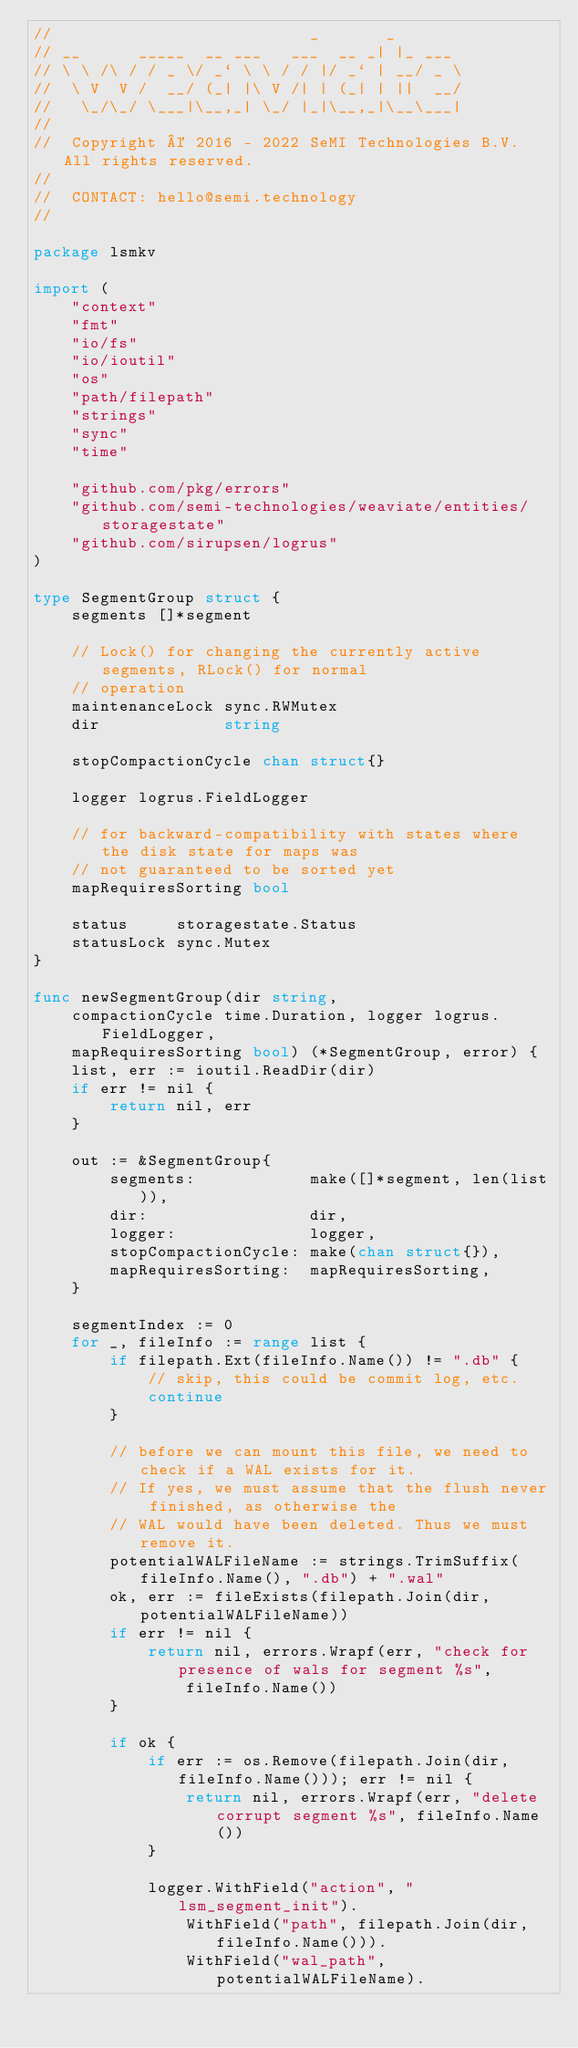<code> <loc_0><loc_0><loc_500><loc_500><_Go_>//                           _       _
// __      _____  __ ___   ___  __ _| |_ ___
// \ \ /\ / / _ \/ _` \ \ / / |/ _` | __/ _ \
//  \ V  V /  __/ (_| |\ V /| | (_| | ||  __/
//   \_/\_/ \___|\__,_| \_/ |_|\__,_|\__\___|
//
//  Copyright © 2016 - 2022 SeMI Technologies B.V. All rights reserved.
//
//  CONTACT: hello@semi.technology
//

package lsmkv

import (
	"context"
	"fmt"
	"io/fs"
	"io/ioutil"
	"os"
	"path/filepath"
	"strings"
	"sync"
	"time"

	"github.com/pkg/errors"
	"github.com/semi-technologies/weaviate/entities/storagestate"
	"github.com/sirupsen/logrus"
)

type SegmentGroup struct {
	segments []*segment

	// Lock() for changing the currently active segments, RLock() for normal
	// operation
	maintenanceLock sync.RWMutex
	dir             string

	stopCompactionCycle chan struct{}

	logger logrus.FieldLogger

	// for backward-compatibility with states where the disk state for maps was
	// not guaranteed to be sorted yet
	mapRequiresSorting bool

	status     storagestate.Status
	statusLock sync.Mutex
}

func newSegmentGroup(dir string,
	compactionCycle time.Duration, logger logrus.FieldLogger,
	mapRequiresSorting bool) (*SegmentGroup, error) {
	list, err := ioutil.ReadDir(dir)
	if err != nil {
		return nil, err
	}

	out := &SegmentGroup{
		segments:            make([]*segment, len(list)),
		dir:                 dir,
		logger:              logger,
		stopCompactionCycle: make(chan struct{}),
		mapRequiresSorting:  mapRequiresSorting,
	}

	segmentIndex := 0
	for _, fileInfo := range list {
		if filepath.Ext(fileInfo.Name()) != ".db" {
			// skip, this could be commit log, etc.
			continue
		}

		// before we can mount this file, we need to check if a WAL exists for it.
		// If yes, we must assume that the flush never finished, as otherwise the
		// WAL would have been deleted. Thus we must remove it.
		potentialWALFileName := strings.TrimSuffix(fileInfo.Name(), ".db") + ".wal"
		ok, err := fileExists(filepath.Join(dir, potentialWALFileName))
		if err != nil {
			return nil, errors.Wrapf(err, "check for presence of wals for segment %s",
				fileInfo.Name())
		}

		if ok {
			if err := os.Remove(filepath.Join(dir, fileInfo.Name())); err != nil {
				return nil, errors.Wrapf(err, "delete corrupt segment %s", fileInfo.Name())
			}

			logger.WithField("action", "lsm_segment_init").
				WithField("path", filepath.Join(dir, fileInfo.Name())).
				WithField("wal_path", potentialWALFileName).</code> 